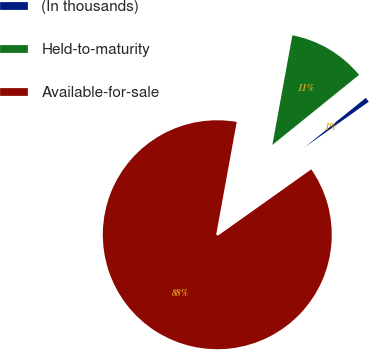<chart> <loc_0><loc_0><loc_500><loc_500><pie_chart><fcel>(In thousands)<fcel>Held-to-maturity<fcel>Available-for-sale<nl><fcel>0.99%<fcel>11.31%<fcel>87.7%<nl></chart> 